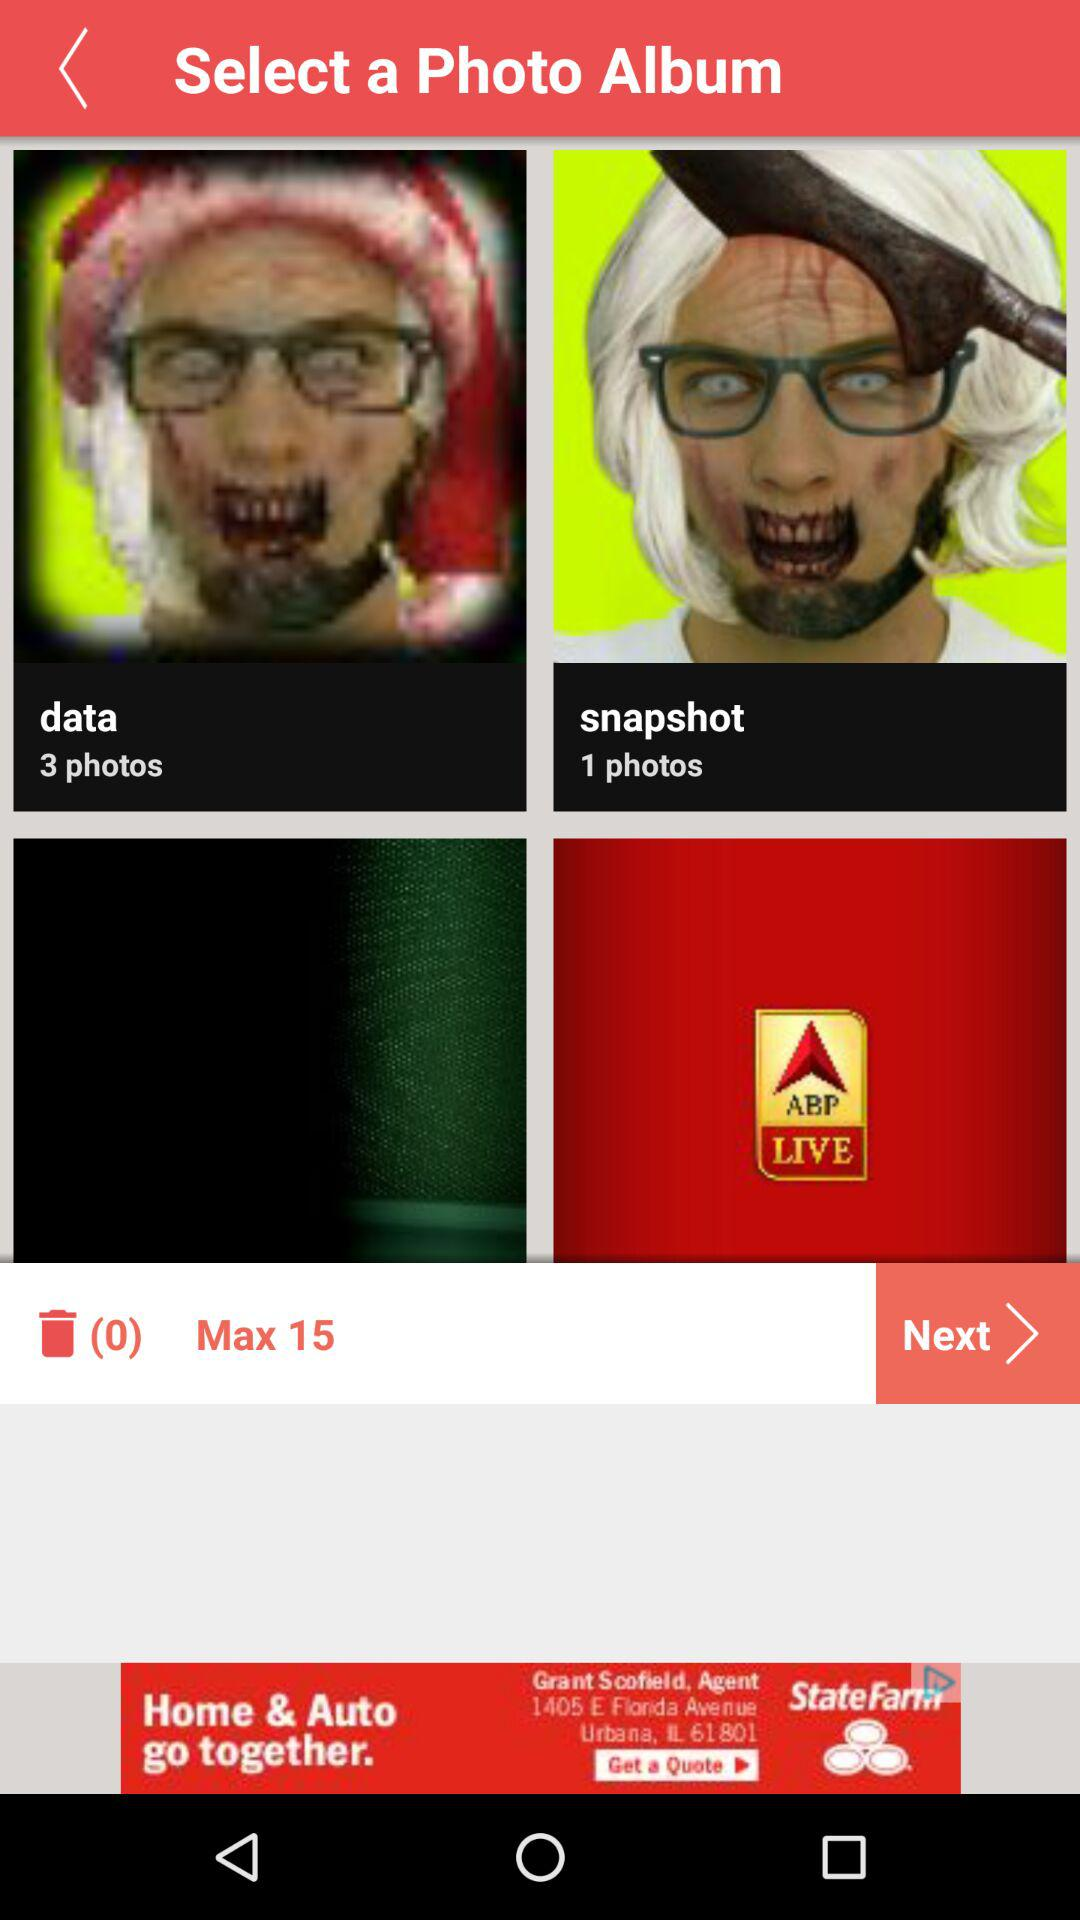How many photos are there in "snapshot"? There is one photo in "snapshot". 